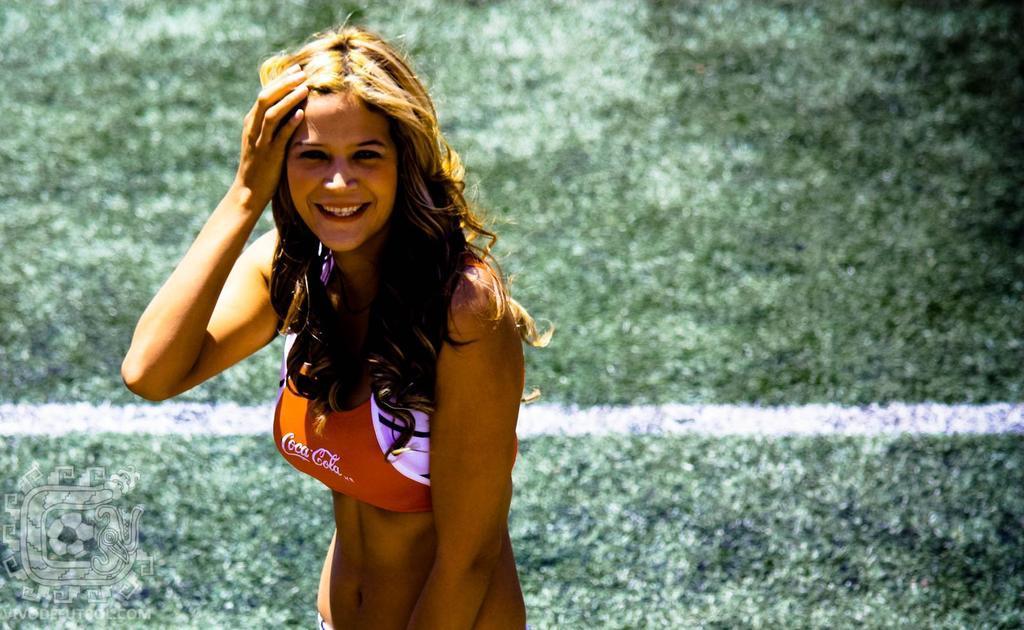Can you describe this image briefly? In this image I can see a woman is standing. The woman is smiling. In the background I can see white color line on the ground. Here I can see a watermark. 